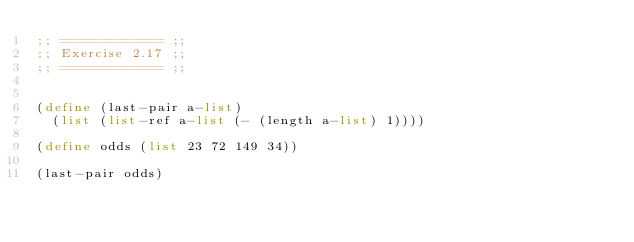<code> <loc_0><loc_0><loc_500><loc_500><_Scheme_>;; ============= ;;
;; Exercise 2.17 ;;
;; ============= ;;


(define (last-pair a-list)
  (list (list-ref a-list (- (length a-list) 1))))

(define odds (list 23 72 149 34))

(last-pair odds)

</code> 